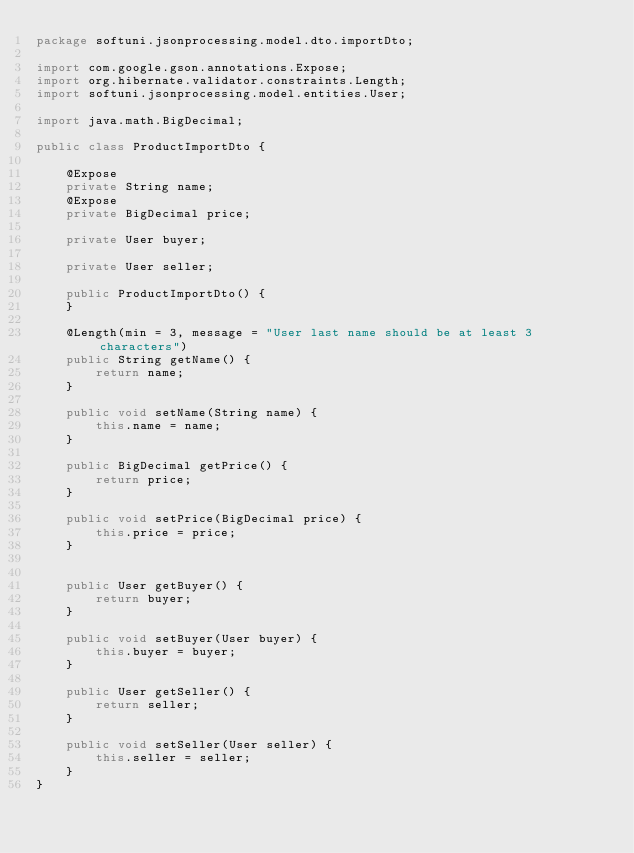Convert code to text. <code><loc_0><loc_0><loc_500><loc_500><_Java_>package softuni.jsonprocessing.model.dto.importDto;

import com.google.gson.annotations.Expose;
import org.hibernate.validator.constraints.Length;
import softuni.jsonprocessing.model.entities.User;

import java.math.BigDecimal;

public class ProductImportDto {

    @Expose
    private String name;
    @Expose
    private BigDecimal price;

    private User buyer;

    private User seller;

    public ProductImportDto() {
    }

    @Length(min = 3, message = "User last name should be at least 3 characters")
    public String getName() {
        return name;
    }

    public void setName(String name) {
        this.name = name;
    }

    public BigDecimal getPrice() {
        return price;
    }

    public void setPrice(BigDecimal price) {
        this.price = price;
    }


    public User getBuyer() {
        return buyer;
    }

    public void setBuyer(User buyer) {
        this.buyer = buyer;
    }

    public User getSeller() {
        return seller;
    }

    public void setSeller(User seller) {
        this.seller = seller;
    }
}
</code> 